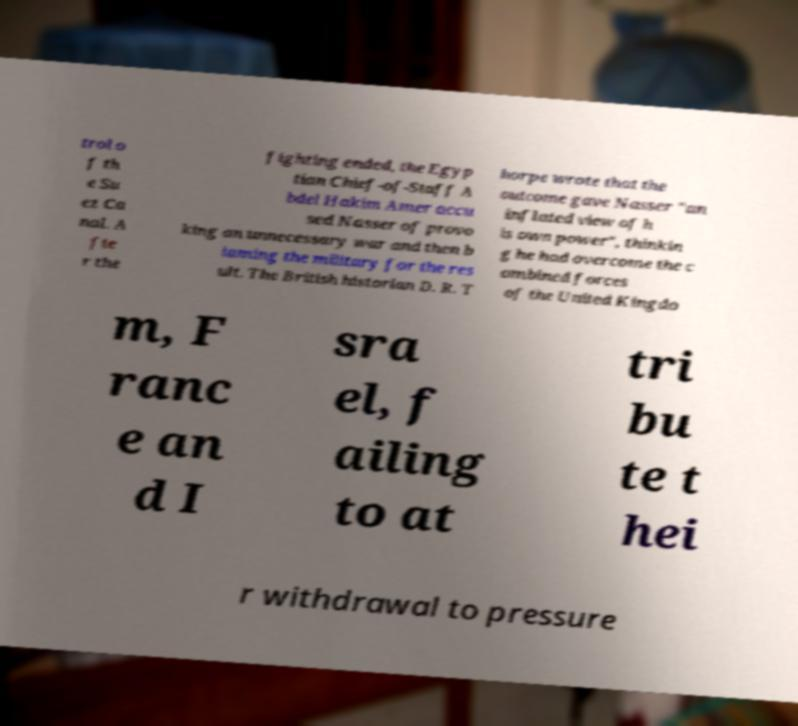Please identify and transcribe the text found in this image. trol o f th e Su ez Ca nal. A fte r the fighting ended, the Egyp tian Chief-of-Staff A bdel Hakim Amer accu sed Nasser of provo king an unnecessary war and then b laming the military for the res ult. The British historian D. R. T horpe wrote that the outcome gave Nasser "an inflated view of h is own power", thinkin g he had overcome the c ombined forces of the United Kingdo m, F ranc e an d I sra el, f ailing to at tri bu te t hei r withdrawal to pressure 